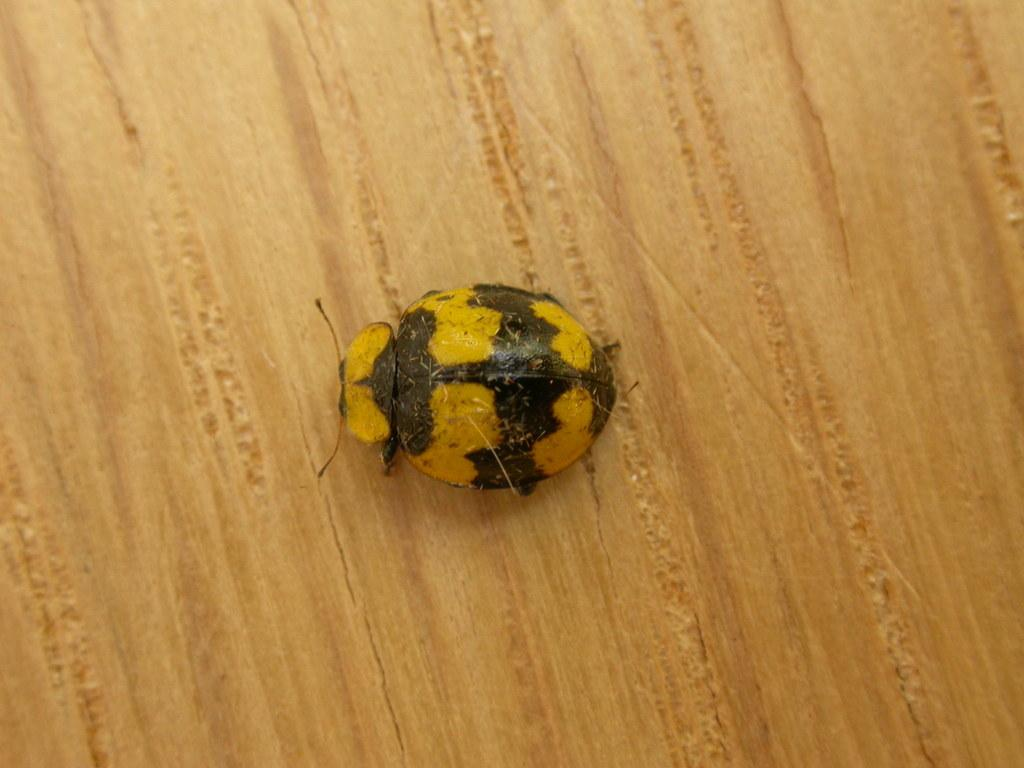What type of creature is present in the image? There is an insect in the image. Where is the insect located in the image? The insect is on a surface. What type of force is being applied to the insect in the image? There is no indication of any force being applied to the insect in the image. 